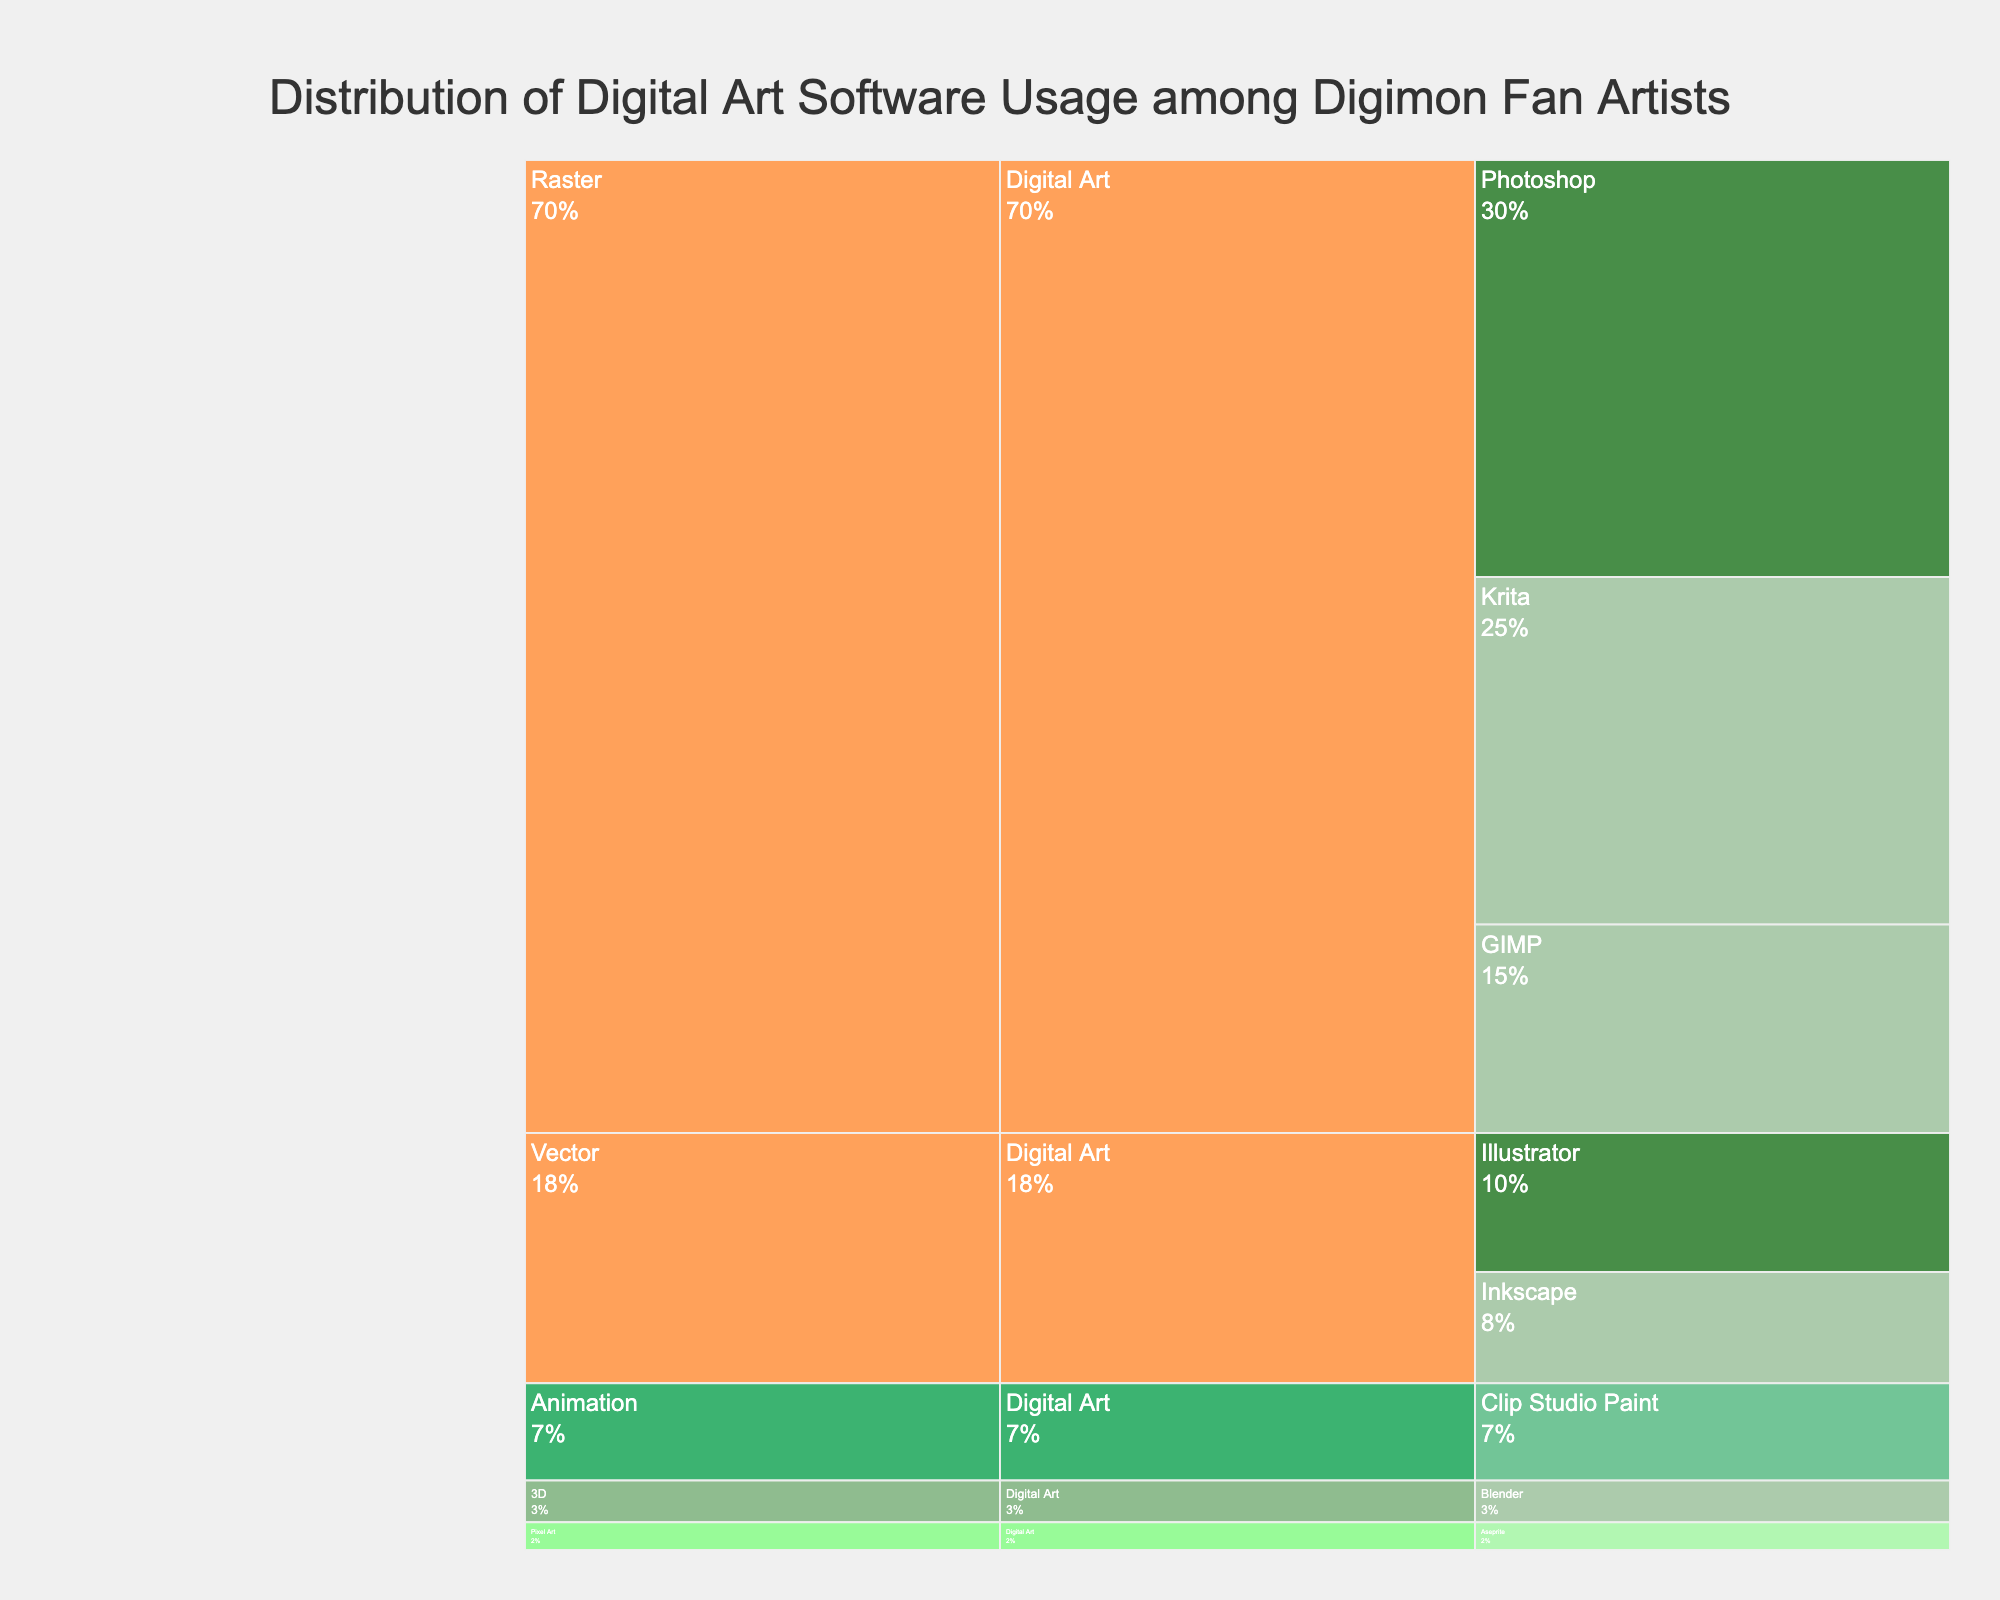How many digital art software options are categorized as Free? The Icicle chart shows the categories, software, and features while highlighting the price range with color. We need to count the software options colored for 'Free' price range. These are: Krita, GIMP, Inkscape, and Blender.
Answer: 4 Which software has the highest usage among Raster software? Check the visual representation for Raster software and see which has the largest segment. Photoshop has the largest segment in the Raster category with a usage of 30.
Answer: Photoshop What is the total usage percentage of all the Free software combined? Sum the usage values of all Free software (Krita, GIMP, Inkscape, Blender). Krita (25) + GIMP (15) + Inkscape (8) + Blender (3) = 51. The total usage is 51 out of 100, thus the percentage is 51%.
Answer: 51% Which vector software is used more, Illustrator or Inkscape, and by how much? Identify the usage values of both software. Illustrator has usage of 10 and Inkscape has 8. The difference is 10 - 8 = 2.
Answer: Illustrator by 2 If combining all categories except Raster, what is their total usage? Sum the usage of non-Raster categories: Illustrator (10) + Inkscape (8) + Clip Studio Paint (7) + Blender (3) + Aseprite (2) = 30.
Answer: 30 What is the price range color for Medium-priced software? The icicle chart uses a specific color scheme. The 'Medium' price range has a color that corresponds to Clip Studio Paint. The color assigned is a shade of green that appears distinct compared to others.
Answer: Green How does the usage of 3D software compare to Animation software? Identify the usage values for 3D (Blender) and Animation (Clip Studio Paint). Blender has a usage of 3, while Clip Studio Paint has a usage of 7. Animation software usage is greater.
Answer: Animation software's usage is higher by 4 What feature is associated with the software having the lowest usage? Examine the Icicle chart to find the software with the lowest usage, which is Aseprite with a usage of 2. The associated feature is Pixel Art.
Answer: Pixel Art Determine the ratio of high-priced software usage to low-priced software usage. Identify the usage values: high-priced (Photoshop 30, Illustrator 10) = 40, low-priced (Aseprite) = 2. Ratio = 40/2.
Answer: 20:1 What category has the highest combined usage? Sum the usage values within each category. Raster: Photoshop (30) + Krita (25) + GIMP (15) = 70. Vector: Illustrator (10) + Inkscape (8) = 18. Animation: Clip Studio Paint (7). 3D: Blender (3). Pixel Art: Aseprite (2). The category with the highest total is Raster with 70.
Answer: Raster 